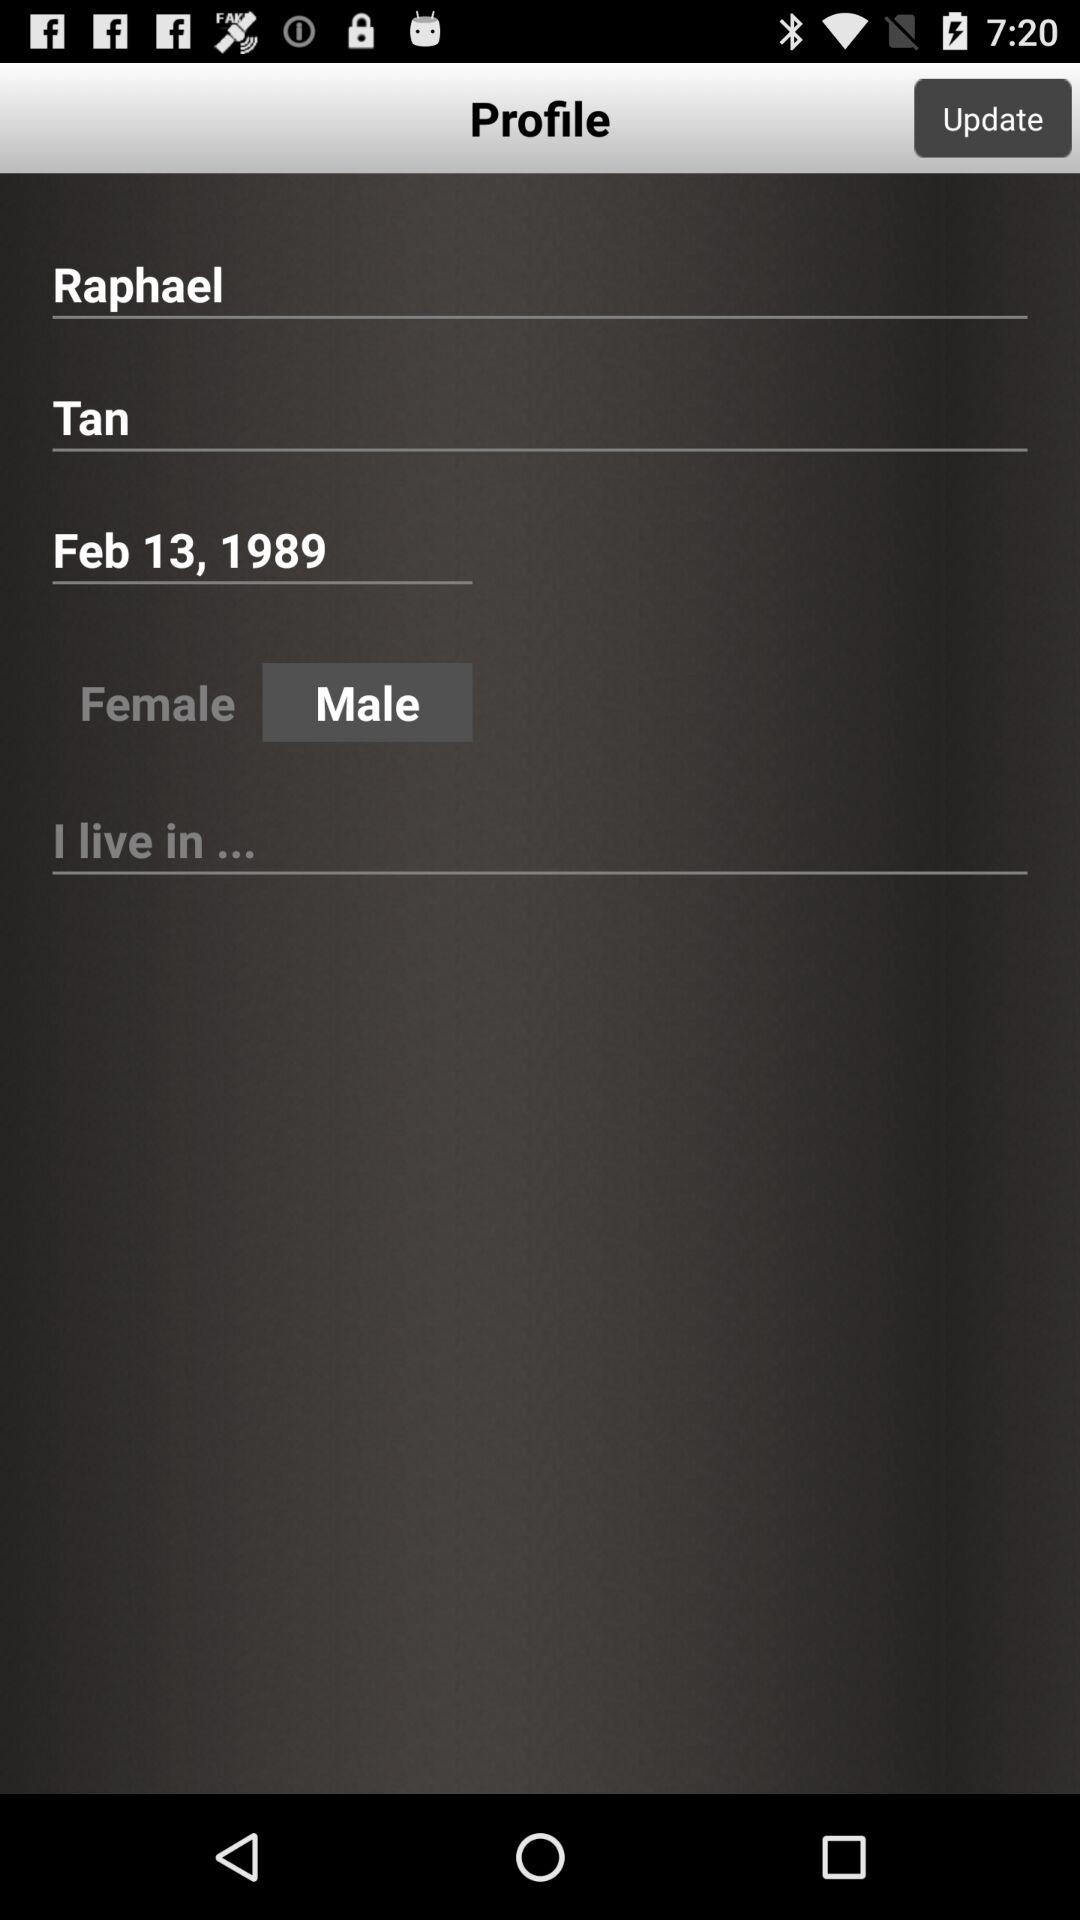What is the name of the user? The name of the user is Raphael. 